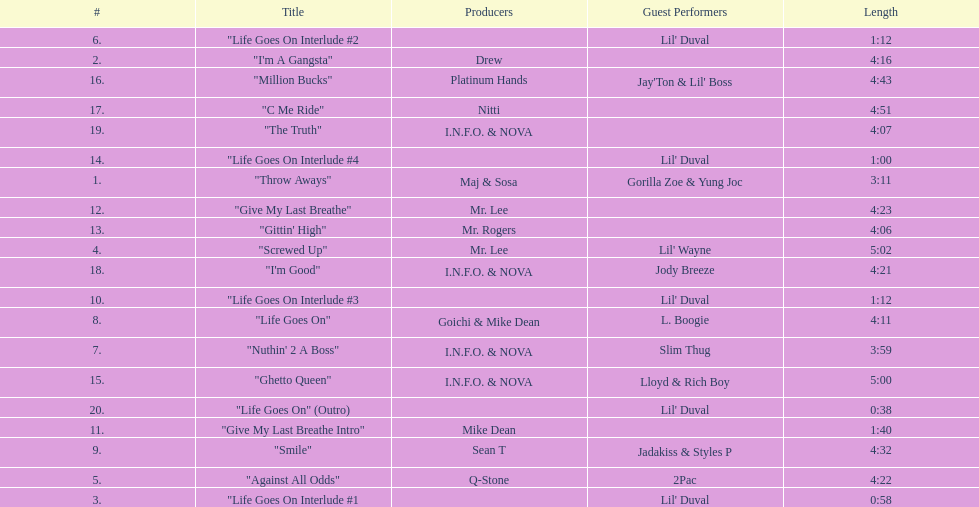In how many tracks does 2pac make an appearance? 1. 